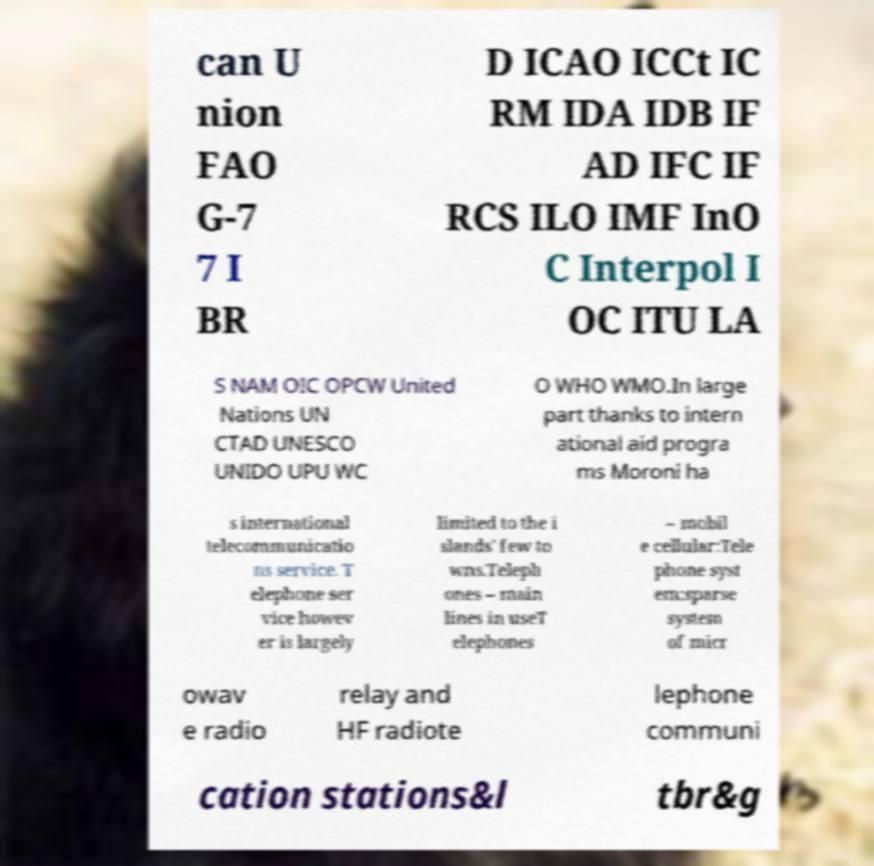Please identify and transcribe the text found in this image. can U nion FAO G-7 7 I BR D ICAO ICCt IC RM IDA IDB IF AD IFC IF RCS ILO IMF InO C Interpol I OC ITU LA S NAM OIC OPCW United Nations UN CTAD UNESCO UNIDO UPU WC O WHO WMO.In large part thanks to intern ational aid progra ms Moroni ha s international telecommunicatio ns service. T elephone ser vice howev er is largely limited to the i slands' few to wns.Teleph ones – main lines in useT elephones – mobil e cellular:Tele phone syst em:sparse system of micr owav e radio relay and HF radiote lephone communi cation stations&l tbr&g 